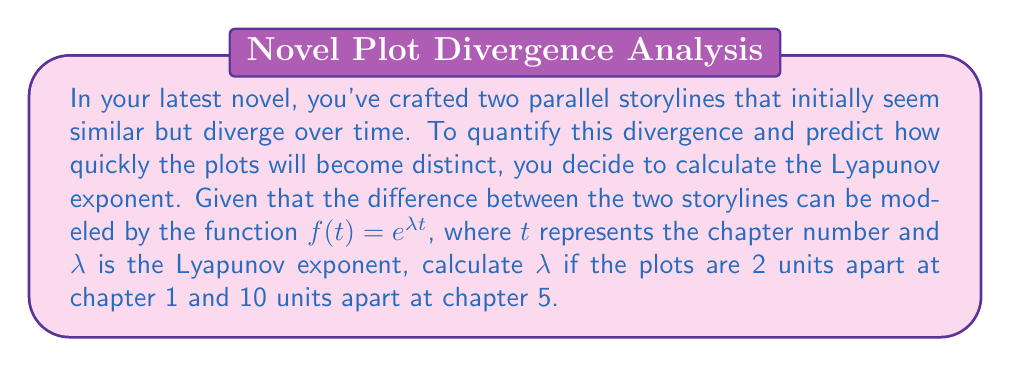Help me with this question. To solve this problem, we'll follow these steps:

1) The Lyapunov exponent $\lambda$ measures the rate of divergence of nearby trajectories. In this case, it measures how quickly our storylines diverge.

2) We're given that $f(t) = e^{\lambda t}$, where $f(t)$ represents the difference between storylines at chapter $t$.

3) We have two data points:
   At $t=1$, $f(1) = 2$
   At $t=5$, $f(5) = 10$

4) Let's use these in our equation:

   For $t=1$: $2 = e^{\lambda \cdot 1} = e^{\lambda}$
   For $t=5$: $10 = e^{\lambda \cdot 5} = e^{5\lambda}$

5) Dividing the second equation by the first:

   $$\frac{10}{2} = \frac{e^{5\lambda}}{e^{\lambda}} = e^{4\lambda}$$

6) Simplify:

   $$5 = e^{4\lambda}$$

7) Take the natural log of both sides:

   $$\ln 5 = 4\lambda$$

8) Solve for $\lambda$:

   $$\lambda = \frac{\ln 5}{4}$$

9) Calculate the value:

   $$\lambda \approx 0.4019$$

This Lyapunov exponent indicates the rate at which your storylines diverge, providing a quantitative measure of how quickly your parallel plots become distinct.
Answer: $\lambda \approx 0.4019$ 